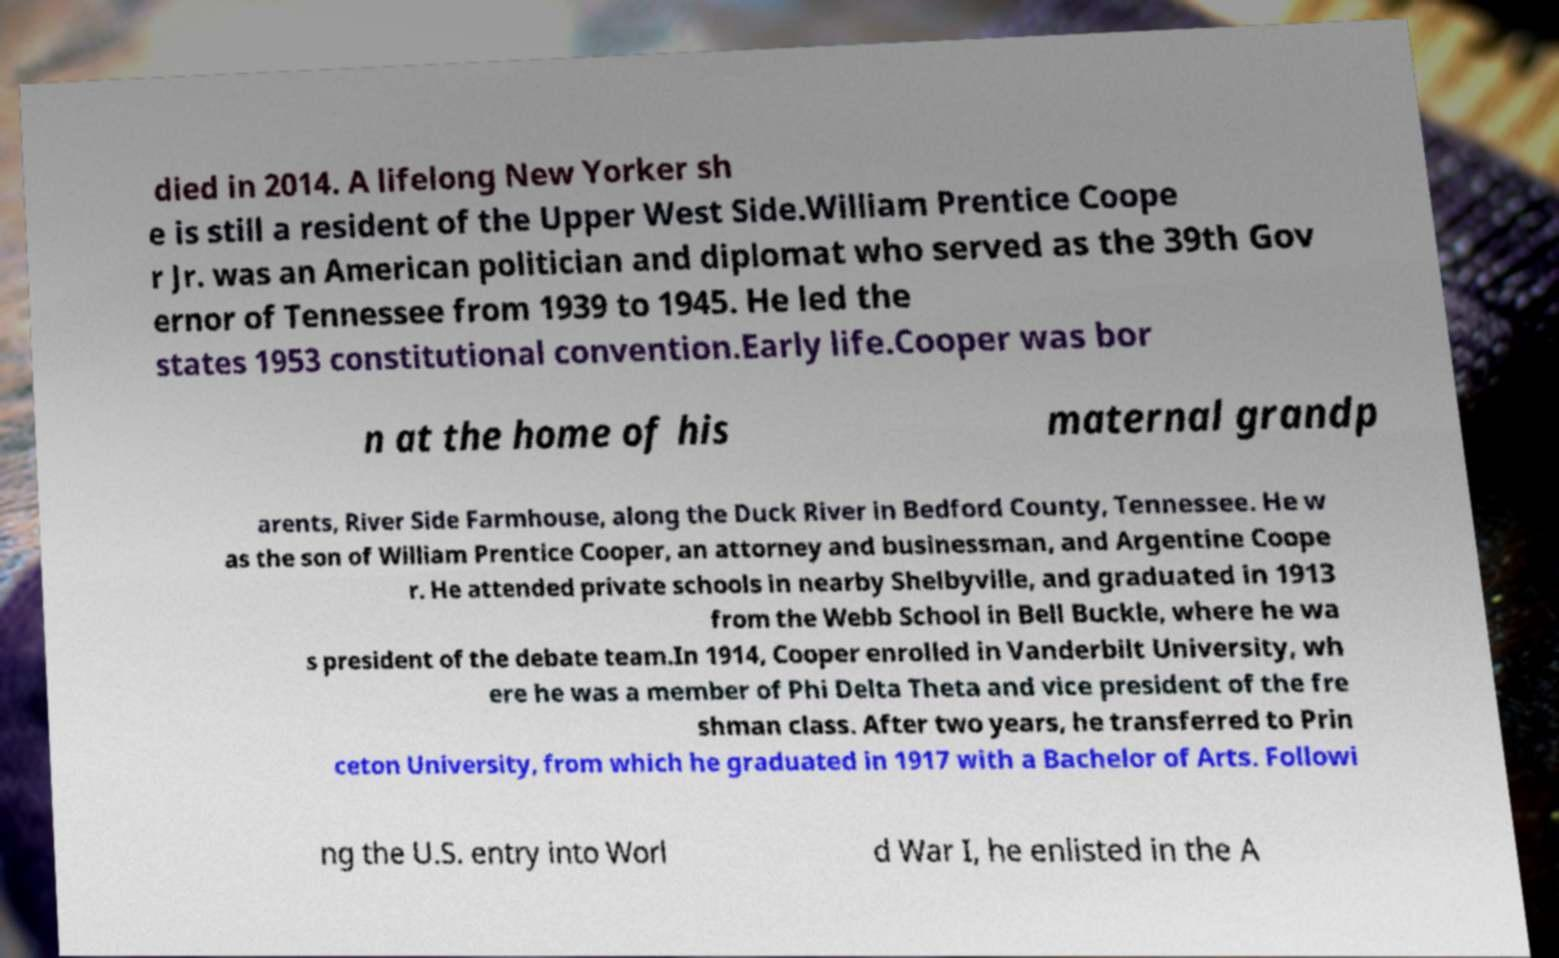Could you assist in decoding the text presented in this image and type it out clearly? died in 2014. A lifelong New Yorker sh e is still a resident of the Upper West Side.William Prentice Coope r Jr. was an American politician and diplomat who served as the 39th Gov ernor of Tennessee from 1939 to 1945. He led the states 1953 constitutional convention.Early life.Cooper was bor n at the home of his maternal grandp arents, River Side Farmhouse, along the Duck River in Bedford County, Tennessee. He w as the son of William Prentice Cooper, an attorney and businessman, and Argentine Coope r. He attended private schools in nearby Shelbyville, and graduated in 1913 from the Webb School in Bell Buckle, where he wa s president of the debate team.In 1914, Cooper enrolled in Vanderbilt University, wh ere he was a member of Phi Delta Theta and vice president of the fre shman class. After two years, he transferred to Prin ceton University, from which he graduated in 1917 with a Bachelor of Arts. Followi ng the U.S. entry into Worl d War I, he enlisted in the A 